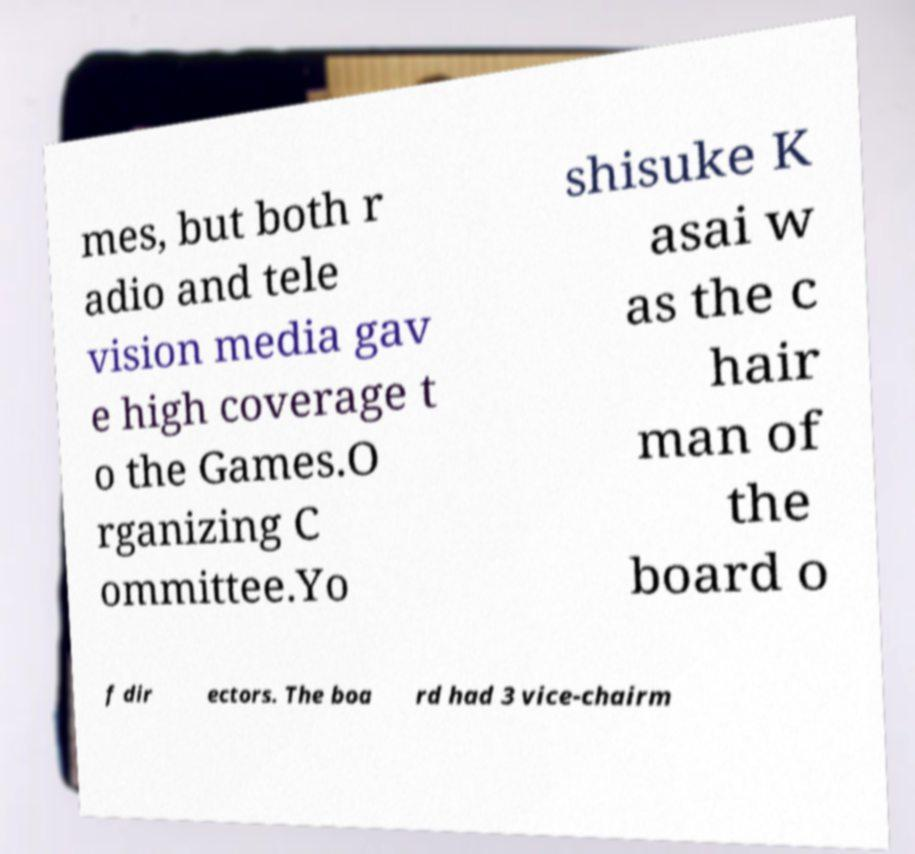For documentation purposes, I need the text within this image transcribed. Could you provide that? mes, but both r adio and tele vision media gav e high coverage t o the Games.O rganizing C ommittee.Yo shisuke K asai w as the c hair man of the board o f dir ectors. The boa rd had 3 vice-chairm 